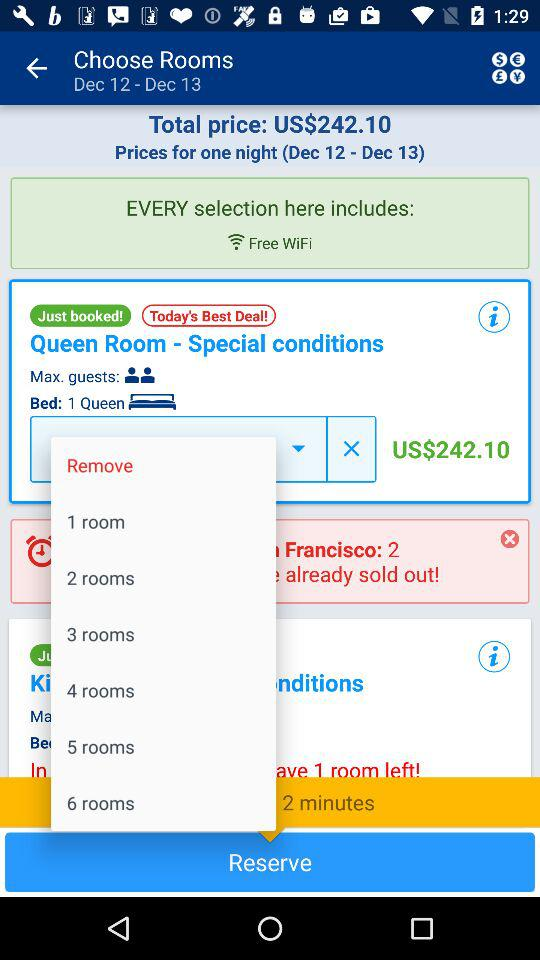What is the total price for one night? The total price for one night is 242.10 USD. 